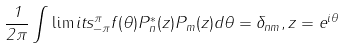<formula> <loc_0><loc_0><loc_500><loc_500>\frac { 1 } { 2 \pi } \int \lim i t s _ { - \pi } ^ { \pi } f ( \theta ) P ^ { * } _ { n } ( z ) P _ { m } ( z ) d \theta = \delta _ { n m } , z = e ^ { i \theta }</formula> 